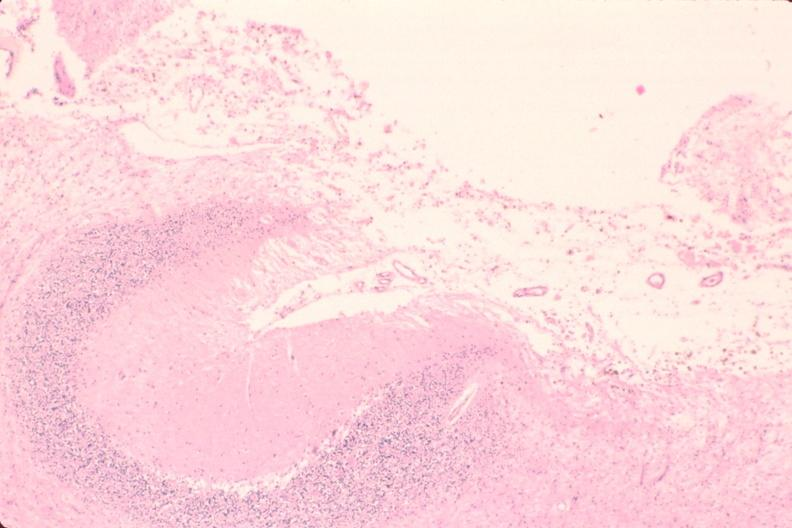does single metastatic appearing lesion show brain, encephalomalasia?
Answer the question using a single word or phrase. No 